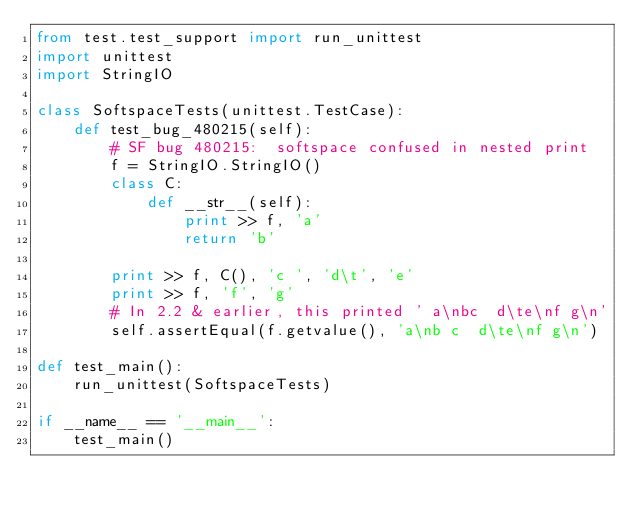<code> <loc_0><loc_0><loc_500><loc_500><_Python_>from test.test_support import run_unittest
import unittest
import StringIO

class SoftspaceTests(unittest.TestCase):
    def test_bug_480215(self):
        # SF bug 480215:  softspace confused in nested print
        f = StringIO.StringIO()
        class C:
            def __str__(self):
                print >> f, 'a'
                return 'b'

        print >> f, C(), 'c ', 'd\t', 'e'
        print >> f, 'f', 'g'
        # In 2.2 & earlier, this printed ' a\nbc  d\te\nf g\n'
        self.assertEqual(f.getvalue(), 'a\nb c  d\te\nf g\n')

def test_main():
    run_unittest(SoftspaceTests)

if __name__ == '__main__':
    test_main()
</code> 